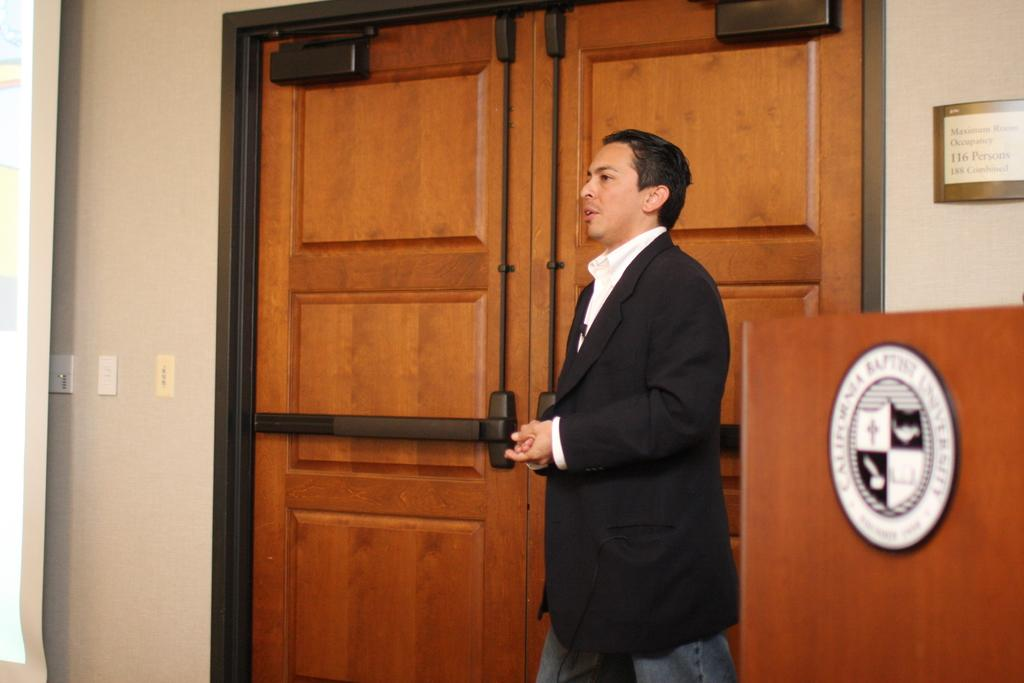Who is present in the image? There is a man in the image. What is the man wearing? The man is wearing a black suit. What architectural features can be seen in the image? There are doors visible in the image. What type of electrical outlets are present in the image? There are sockets on the wall in the image. What type of zinc object is present in the image? There is no zinc object present in the image. What is inside the box that the man is holding in the image? The man is not holding a box in the image. 